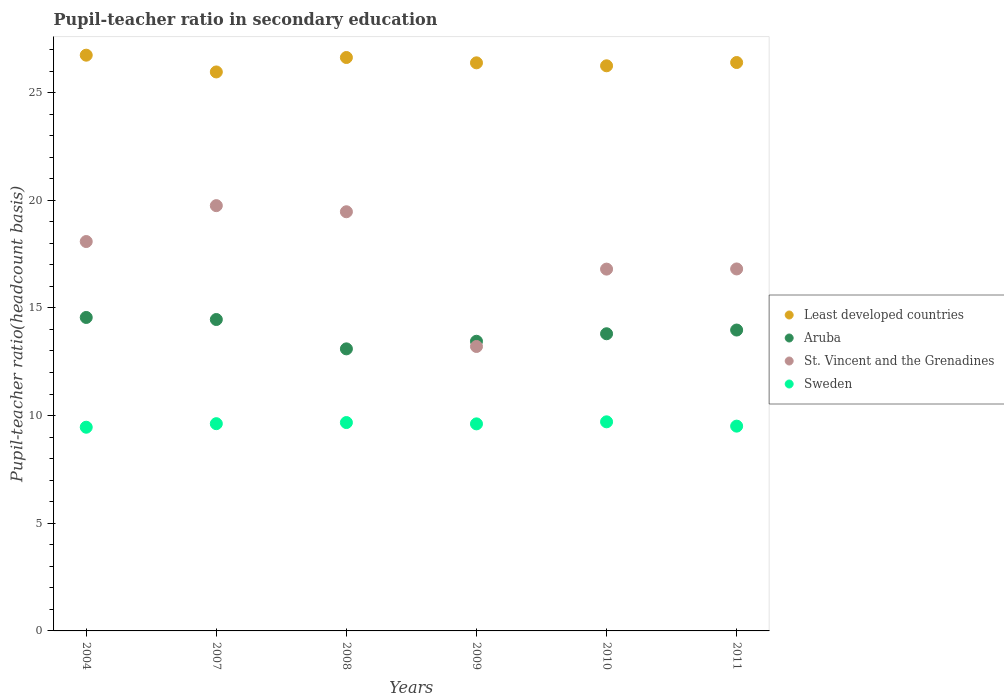Is the number of dotlines equal to the number of legend labels?
Ensure brevity in your answer.  Yes. What is the pupil-teacher ratio in secondary education in Aruba in 2009?
Make the answer very short. 13.45. Across all years, what is the maximum pupil-teacher ratio in secondary education in Sweden?
Provide a succinct answer. 9.71. Across all years, what is the minimum pupil-teacher ratio in secondary education in Aruba?
Make the answer very short. 13.1. In which year was the pupil-teacher ratio in secondary education in Aruba minimum?
Provide a short and direct response. 2008. What is the total pupil-teacher ratio in secondary education in Aruba in the graph?
Keep it short and to the point. 83.35. What is the difference between the pupil-teacher ratio in secondary education in St. Vincent and the Grenadines in 2004 and that in 2011?
Keep it short and to the point. 1.27. What is the difference between the pupil-teacher ratio in secondary education in Aruba in 2009 and the pupil-teacher ratio in secondary education in Least developed countries in 2010?
Your response must be concise. -12.79. What is the average pupil-teacher ratio in secondary education in St. Vincent and the Grenadines per year?
Your answer should be compact. 17.35. In the year 2007, what is the difference between the pupil-teacher ratio in secondary education in Sweden and pupil-teacher ratio in secondary education in Aruba?
Ensure brevity in your answer.  -4.84. What is the ratio of the pupil-teacher ratio in secondary education in Aruba in 2004 to that in 2009?
Make the answer very short. 1.08. Is the pupil-teacher ratio in secondary education in Sweden in 2009 less than that in 2010?
Keep it short and to the point. Yes. Is the difference between the pupil-teacher ratio in secondary education in Sweden in 2008 and 2009 greater than the difference between the pupil-teacher ratio in secondary education in Aruba in 2008 and 2009?
Keep it short and to the point. Yes. What is the difference between the highest and the second highest pupil-teacher ratio in secondary education in Aruba?
Your answer should be compact. 0.1. What is the difference between the highest and the lowest pupil-teacher ratio in secondary education in St. Vincent and the Grenadines?
Your answer should be compact. 6.54. Is the sum of the pupil-teacher ratio in secondary education in Aruba in 2004 and 2010 greater than the maximum pupil-teacher ratio in secondary education in Least developed countries across all years?
Give a very brief answer. Yes. Is it the case that in every year, the sum of the pupil-teacher ratio in secondary education in Least developed countries and pupil-teacher ratio in secondary education in Aruba  is greater than the sum of pupil-teacher ratio in secondary education in St. Vincent and the Grenadines and pupil-teacher ratio in secondary education in Sweden?
Give a very brief answer. Yes. Does the pupil-teacher ratio in secondary education in St. Vincent and the Grenadines monotonically increase over the years?
Offer a very short reply. No. Is the pupil-teacher ratio in secondary education in St. Vincent and the Grenadines strictly greater than the pupil-teacher ratio in secondary education in Sweden over the years?
Keep it short and to the point. Yes. Is the pupil-teacher ratio in secondary education in Sweden strictly less than the pupil-teacher ratio in secondary education in St. Vincent and the Grenadines over the years?
Ensure brevity in your answer.  Yes. How many years are there in the graph?
Your response must be concise. 6. Does the graph contain any zero values?
Give a very brief answer. No. Does the graph contain grids?
Provide a short and direct response. No. Where does the legend appear in the graph?
Offer a very short reply. Center right. What is the title of the graph?
Offer a terse response. Pupil-teacher ratio in secondary education. Does "Central Europe" appear as one of the legend labels in the graph?
Provide a short and direct response. No. What is the label or title of the Y-axis?
Your response must be concise. Pupil-teacher ratio(headcount basis). What is the Pupil-teacher ratio(headcount basis) of Least developed countries in 2004?
Your answer should be very brief. 26.74. What is the Pupil-teacher ratio(headcount basis) in Aruba in 2004?
Ensure brevity in your answer.  14.56. What is the Pupil-teacher ratio(headcount basis) in St. Vincent and the Grenadines in 2004?
Your answer should be compact. 18.08. What is the Pupil-teacher ratio(headcount basis) in Sweden in 2004?
Provide a succinct answer. 9.46. What is the Pupil-teacher ratio(headcount basis) of Least developed countries in 2007?
Offer a terse response. 25.96. What is the Pupil-teacher ratio(headcount basis) in Aruba in 2007?
Offer a terse response. 14.46. What is the Pupil-teacher ratio(headcount basis) in St. Vincent and the Grenadines in 2007?
Offer a terse response. 19.75. What is the Pupil-teacher ratio(headcount basis) of Sweden in 2007?
Make the answer very short. 9.62. What is the Pupil-teacher ratio(headcount basis) of Least developed countries in 2008?
Make the answer very short. 26.63. What is the Pupil-teacher ratio(headcount basis) of Aruba in 2008?
Give a very brief answer. 13.1. What is the Pupil-teacher ratio(headcount basis) of St. Vincent and the Grenadines in 2008?
Your answer should be compact. 19.47. What is the Pupil-teacher ratio(headcount basis) in Sweden in 2008?
Offer a terse response. 9.68. What is the Pupil-teacher ratio(headcount basis) in Least developed countries in 2009?
Ensure brevity in your answer.  26.38. What is the Pupil-teacher ratio(headcount basis) of Aruba in 2009?
Give a very brief answer. 13.45. What is the Pupil-teacher ratio(headcount basis) in St. Vincent and the Grenadines in 2009?
Offer a very short reply. 13.21. What is the Pupil-teacher ratio(headcount basis) of Sweden in 2009?
Make the answer very short. 9.62. What is the Pupil-teacher ratio(headcount basis) of Least developed countries in 2010?
Make the answer very short. 26.25. What is the Pupil-teacher ratio(headcount basis) of Aruba in 2010?
Provide a succinct answer. 13.8. What is the Pupil-teacher ratio(headcount basis) in St. Vincent and the Grenadines in 2010?
Offer a terse response. 16.8. What is the Pupil-teacher ratio(headcount basis) of Sweden in 2010?
Offer a terse response. 9.71. What is the Pupil-teacher ratio(headcount basis) of Least developed countries in 2011?
Make the answer very short. 26.4. What is the Pupil-teacher ratio(headcount basis) of Aruba in 2011?
Make the answer very short. 13.97. What is the Pupil-teacher ratio(headcount basis) of St. Vincent and the Grenadines in 2011?
Offer a very short reply. 16.81. What is the Pupil-teacher ratio(headcount basis) in Sweden in 2011?
Offer a terse response. 9.51. Across all years, what is the maximum Pupil-teacher ratio(headcount basis) in Least developed countries?
Make the answer very short. 26.74. Across all years, what is the maximum Pupil-teacher ratio(headcount basis) of Aruba?
Ensure brevity in your answer.  14.56. Across all years, what is the maximum Pupil-teacher ratio(headcount basis) in St. Vincent and the Grenadines?
Your answer should be very brief. 19.75. Across all years, what is the maximum Pupil-teacher ratio(headcount basis) of Sweden?
Offer a terse response. 9.71. Across all years, what is the minimum Pupil-teacher ratio(headcount basis) in Least developed countries?
Your answer should be very brief. 25.96. Across all years, what is the minimum Pupil-teacher ratio(headcount basis) of Aruba?
Make the answer very short. 13.1. Across all years, what is the minimum Pupil-teacher ratio(headcount basis) in St. Vincent and the Grenadines?
Provide a short and direct response. 13.21. Across all years, what is the minimum Pupil-teacher ratio(headcount basis) in Sweden?
Keep it short and to the point. 9.46. What is the total Pupil-teacher ratio(headcount basis) of Least developed countries in the graph?
Make the answer very short. 158.35. What is the total Pupil-teacher ratio(headcount basis) in Aruba in the graph?
Your response must be concise. 83.35. What is the total Pupil-teacher ratio(headcount basis) of St. Vincent and the Grenadines in the graph?
Your answer should be very brief. 104.12. What is the total Pupil-teacher ratio(headcount basis) in Sweden in the graph?
Offer a terse response. 57.6. What is the difference between the Pupil-teacher ratio(headcount basis) in Least developed countries in 2004 and that in 2007?
Give a very brief answer. 0.78. What is the difference between the Pupil-teacher ratio(headcount basis) of Aruba in 2004 and that in 2007?
Offer a terse response. 0.1. What is the difference between the Pupil-teacher ratio(headcount basis) in St. Vincent and the Grenadines in 2004 and that in 2007?
Your response must be concise. -1.67. What is the difference between the Pupil-teacher ratio(headcount basis) of Sweden in 2004 and that in 2007?
Ensure brevity in your answer.  -0.16. What is the difference between the Pupil-teacher ratio(headcount basis) in Least developed countries in 2004 and that in 2008?
Provide a succinct answer. 0.11. What is the difference between the Pupil-teacher ratio(headcount basis) in Aruba in 2004 and that in 2008?
Ensure brevity in your answer.  1.46. What is the difference between the Pupil-teacher ratio(headcount basis) in St. Vincent and the Grenadines in 2004 and that in 2008?
Give a very brief answer. -1.38. What is the difference between the Pupil-teacher ratio(headcount basis) in Sweden in 2004 and that in 2008?
Your response must be concise. -0.22. What is the difference between the Pupil-teacher ratio(headcount basis) of Least developed countries in 2004 and that in 2009?
Your answer should be very brief. 0.36. What is the difference between the Pupil-teacher ratio(headcount basis) of Aruba in 2004 and that in 2009?
Offer a very short reply. 1.11. What is the difference between the Pupil-teacher ratio(headcount basis) of St. Vincent and the Grenadines in 2004 and that in 2009?
Make the answer very short. 4.87. What is the difference between the Pupil-teacher ratio(headcount basis) of Sweden in 2004 and that in 2009?
Offer a terse response. -0.16. What is the difference between the Pupil-teacher ratio(headcount basis) of Least developed countries in 2004 and that in 2010?
Keep it short and to the point. 0.49. What is the difference between the Pupil-teacher ratio(headcount basis) of Aruba in 2004 and that in 2010?
Offer a terse response. 0.76. What is the difference between the Pupil-teacher ratio(headcount basis) in St. Vincent and the Grenadines in 2004 and that in 2010?
Provide a succinct answer. 1.28. What is the difference between the Pupil-teacher ratio(headcount basis) of Sweden in 2004 and that in 2010?
Provide a succinct answer. -0.25. What is the difference between the Pupil-teacher ratio(headcount basis) in Least developed countries in 2004 and that in 2011?
Offer a terse response. 0.34. What is the difference between the Pupil-teacher ratio(headcount basis) of Aruba in 2004 and that in 2011?
Offer a very short reply. 0.58. What is the difference between the Pupil-teacher ratio(headcount basis) in St. Vincent and the Grenadines in 2004 and that in 2011?
Offer a terse response. 1.27. What is the difference between the Pupil-teacher ratio(headcount basis) of Sweden in 2004 and that in 2011?
Offer a very short reply. -0.05. What is the difference between the Pupil-teacher ratio(headcount basis) in Least developed countries in 2007 and that in 2008?
Offer a very short reply. -0.67. What is the difference between the Pupil-teacher ratio(headcount basis) of Aruba in 2007 and that in 2008?
Offer a terse response. 1.36. What is the difference between the Pupil-teacher ratio(headcount basis) in St. Vincent and the Grenadines in 2007 and that in 2008?
Make the answer very short. 0.28. What is the difference between the Pupil-teacher ratio(headcount basis) in Sweden in 2007 and that in 2008?
Make the answer very short. -0.05. What is the difference between the Pupil-teacher ratio(headcount basis) in Least developed countries in 2007 and that in 2009?
Ensure brevity in your answer.  -0.42. What is the difference between the Pupil-teacher ratio(headcount basis) of Aruba in 2007 and that in 2009?
Keep it short and to the point. 1.01. What is the difference between the Pupil-teacher ratio(headcount basis) in St. Vincent and the Grenadines in 2007 and that in 2009?
Keep it short and to the point. 6.54. What is the difference between the Pupil-teacher ratio(headcount basis) of Sweden in 2007 and that in 2009?
Give a very brief answer. 0.01. What is the difference between the Pupil-teacher ratio(headcount basis) in Least developed countries in 2007 and that in 2010?
Offer a terse response. -0.29. What is the difference between the Pupil-teacher ratio(headcount basis) of Aruba in 2007 and that in 2010?
Offer a very short reply. 0.66. What is the difference between the Pupil-teacher ratio(headcount basis) in St. Vincent and the Grenadines in 2007 and that in 2010?
Make the answer very short. 2.95. What is the difference between the Pupil-teacher ratio(headcount basis) in Sweden in 2007 and that in 2010?
Your answer should be compact. -0.09. What is the difference between the Pupil-teacher ratio(headcount basis) in Least developed countries in 2007 and that in 2011?
Your answer should be very brief. -0.44. What is the difference between the Pupil-teacher ratio(headcount basis) of Aruba in 2007 and that in 2011?
Provide a short and direct response. 0.49. What is the difference between the Pupil-teacher ratio(headcount basis) in St. Vincent and the Grenadines in 2007 and that in 2011?
Provide a short and direct response. 2.94. What is the difference between the Pupil-teacher ratio(headcount basis) in Sweden in 2007 and that in 2011?
Your answer should be very brief. 0.11. What is the difference between the Pupil-teacher ratio(headcount basis) of Least developed countries in 2008 and that in 2009?
Your response must be concise. 0.25. What is the difference between the Pupil-teacher ratio(headcount basis) in Aruba in 2008 and that in 2009?
Provide a short and direct response. -0.35. What is the difference between the Pupil-teacher ratio(headcount basis) in St. Vincent and the Grenadines in 2008 and that in 2009?
Make the answer very short. 6.26. What is the difference between the Pupil-teacher ratio(headcount basis) of Sweden in 2008 and that in 2009?
Keep it short and to the point. 0.06. What is the difference between the Pupil-teacher ratio(headcount basis) of Least developed countries in 2008 and that in 2010?
Your response must be concise. 0.38. What is the difference between the Pupil-teacher ratio(headcount basis) of Aruba in 2008 and that in 2010?
Make the answer very short. -0.7. What is the difference between the Pupil-teacher ratio(headcount basis) in St. Vincent and the Grenadines in 2008 and that in 2010?
Provide a short and direct response. 2.66. What is the difference between the Pupil-teacher ratio(headcount basis) in Sweden in 2008 and that in 2010?
Provide a succinct answer. -0.03. What is the difference between the Pupil-teacher ratio(headcount basis) in Least developed countries in 2008 and that in 2011?
Provide a short and direct response. 0.23. What is the difference between the Pupil-teacher ratio(headcount basis) of Aruba in 2008 and that in 2011?
Your answer should be compact. -0.87. What is the difference between the Pupil-teacher ratio(headcount basis) in St. Vincent and the Grenadines in 2008 and that in 2011?
Your response must be concise. 2.66. What is the difference between the Pupil-teacher ratio(headcount basis) of Sweden in 2008 and that in 2011?
Keep it short and to the point. 0.17. What is the difference between the Pupil-teacher ratio(headcount basis) of Least developed countries in 2009 and that in 2010?
Your response must be concise. 0.14. What is the difference between the Pupil-teacher ratio(headcount basis) of Aruba in 2009 and that in 2010?
Provide a short and direct response. -0.35. What is the difference between the Pupil-teacher ratio(headcount basis) in St. Vincent and the Grenadines in 2009 and that in 2010?
Offer a terse response. -3.59. What is the difference between the Pupil-teacher ratio(headcount basis) in Sweden in 2009 and that in 2010?
Ensure brevity in your answer.  -0.1. What is the difference between the Pupil-teacher ratio(headcount basis) of Least developed countries in 2009 and that in 2011?
Ensure brevity in your answer.  -0.01. What is the difference between the Pupil-teacher ratio(headcount basis) of Aruba in 2009 and that in 2011?
Your answer should be very brief. -0.52. What is the difference between the Pupil-teacher ratio(headcount basis) of St. Vincent and the Grenadines in 2009 and that in 2011?
Keep it short and to the point. -3.6. What is the difference between the Pupil-teacher ratio(headcount basis) of Sweden in 2009 and that in 2011?
Your answer should be compact. 0.1. What is the difference between the Pupil-teacher ratio(headcount basis) in Least developed countries in 2010 and that in 2011?
Offer a very short reply. -0.15. What is the difference between the Pupil-teacher ratio(headcount basis) of Aruba in 2010 and that in 2011?
Offer a terse response. -0.17. What is the difference between the Pupil-teacher ratio(headcount basis) of St. Vincent and the Grenadines in 2010 and that in 2011?
Provide a short and direct response. -0.01. What is the difference between the Pupil-teacher ratio(headcount basis) of Sweden in 2010 and that in 2011?
Ensure brevity in your answer.  0.2. What is the difference between the Pupil-teacher ratio(headcount basis) in Least developed countries in 2004 and the Pupil-teacher ratio(headcount basis) in Aruba in 2007?
Keep it short and to the point. 12.28. What is the difference between the Pupil-teacher ratio(headcount basis) of Least developed countries in 2004 and the Pupil-teacher ratio(headcount basis) of St. Vincent and the Grenadines in 2007?
Your answer should be compact. 6.99. What is the difference between the Pupil-teacher ratio(headcount basis) of Least developed countries in 2004 and the Pupil-teacher ratio(headcount basis) of Sweden in 2007?
Your response must be concise. 17.11. What is the difference between the Pupil-teacher ratio(headcount basis) in Aruba in 2004 and the Pupil-teacher ratio(headcount basis) in St. Vincent and the Grenadines in 2007?
Ensure brevity in your answer.  -5.19. What is the difference between the Pupil-teacher ratio(headcount basis) of Aruba in 2004 and the Pupil-teacher ratio(headcount basis) of Sweden in 2007?
Give a very brief answer. 4.93. What is the difference between the Pupil-teacher ratio(headcount basis) in St. Vincent and the Grenadines in 2004 and the Pupil-teacher ratio(headcount basis) in Sweden in 2007?
Make the answer very short. 8.46. What is the difference between the Pupil-teacher ratio(headcount basis) in Least developed countries in 2004 and the Pupil-teacher ratio(headcount basis) in Aruba in 2008?
Make the answer very short. 13.64. What is the difference between the Pupil-teacher ratio(headcount basis) of Least developed countries in 2004 and the Pupil-teacher ratio(headcount basis) of St. Vincent and the Grenadines in 2008?
Offer a very short reply. 7.27. What is the difference between the Pupil-teacher ratio(headcount basis) in Least developed countries in 2004 and the Pupil-teacher ratio(headcount basis) in Sweden in 2008?
Offer a very short reply. 17.06. What is the difference between the Pupil-teacher ratio(headcount basis) in Aruba in 2004 and the Pupil-teacher ratio(headcount basis) in St. Vincent and the Grenadines in 2008?
Keep it short and to the point. -4.91. What is the difference between the Pupil-teacher ratio(headcount basis) of Aruba in 2004 and the Pupil-teacher ratio(headcount basis) of Sweden in 2008?
Your response must be concise. 4.88. What is the difference between the Pupil-teacher ratio(headcount basis) in St. Vincent and the Grenadines in 2004 and the Pupil-teacher ratio(headcount basis) in Sweden in 2008?
Ensure brevity in your answer.  8.41. What is the difference between the Pupil-teacher ratio(headcount basis) in Least developed countries in 2004 and the Pupil-teacher ratio(headcount basis) in Aruba in 2009?
Your answer should be very brief. 13.29. What is the difference between the Pupil-teacher ratio(headcount basis) in Least developed countries in 2004 and the Pupil-teacher ratio(headcount basis) in St. Vincent and the Grenadines in 2009?
Your response must be concise. 13.53. What is the difference between the Pupil-teacher ratio(headcount basis) of Least developed countries in 2004 and the Pupil-teacher ratio(headcount basis) of Sweden in 2009?
Keep it short and to the point. 17.12. What is the difference between the Pupil-teacher ratio(headcount basis) in Aruba in 2004 and the Pupil-teacher ratio(headcount basis) in St. Vincent and the Grenadines in 2009?
Offer a very short reply. 1.35. What is the difference between the Pupil-teacher ratio(headcount basis) in Aruba in 2004 and the Pupil-teacher ratio(headcount basis) in Sweden in 2009?
Provide a short and direct response. 4.94. What is the difference between the Pupil-teacher ratio(headcount basis) in St. Vincent and the Grenadines in 2004 and the Pupil-teacher ratio(headcount basis) in Sweden in 2009?
Offer a very short reply. 8.47. What is the difference between the Pupil-teacher ratio(headcount basis) in Least developed countries in 2004 and the Pupil-teacher ratio(headcount basis) in Aruba in 2010?
Your answer should be compact. 12.94. What is the difference between the Pupil-teacher ratio(headcount basis) of Least developed countries in 2004 and the Pupil-teacher ratio(headcount basis) of St. Vincent and the Grenadines in 2010?
Provide a succinct answer. 9.94. What is the difference between the Pupil-teacher ratio(headcount basis) in Least developed countries in 2004 and the Pupil-teacher ratio(headcount basis) in Sweden in 2010?
Provide a succinct answer. 17.03. What is the difference between the Pupil-teacher ratio(headcount basis) of Aruba in 2004 and the Pupil-teacher ratio(headcount basis) of St. Vincent and the Grenadines in 2010?
Offer a terse response. -2.25. What is the difference between the Pupil-teacher ratio(headcount basis) of Aruba in 2004 and the Pupil-teacher ratio(headcount basis) of Sweden in 2010?
Offer a very short reply. 4.85. What is the difference between the Pupil-teacher ratio(headcount basis) in St. Vincent and the Grenadines in 2004 and the Pupil-teacher ratio(headcount basis) in Sweden in 2010?
Offer a very short reply. 8.37. What is the difference between the Pupil-teacher ratio(headcount basis) of Least developed countries in 2004 and the Pupil-teacher ratio(headcount basis) of Aruba in 2011?
Your answer should be compact. 12.76. What is the difference between the Pupil-teacher ratio(headcount basis) in Least developed countries in 2004 and the Pupil-teacher ratio(headcount basis) in St. Vincent and the Grenadines in 2011?
Your answer should be very brief. 9.93. What is the difference between the Pupil-teacher ratio(headcount basis) of Least developed countries in 2004 and the Pupil-teacher ratio(headcount basis) of Sweden in 2011?
Keep it short and to the point. 17.23. What is the difference between the Pupil-teacher ratio(headcount basis) of Aruba in 2004 and the Pupil-teacher ratio(headcount basis) of St. Vincent and the Grenadines in 2011?
Provide a short and direct response. -2.25. What is the difference between the Pupil-teacher ratio(headcount basis) of Aruba in 2004 and the Pupil-teacher ratio(headcount basis) of Sweden in 2011?
Provide a short and direct response. 5.05. What is the difference between the Pupil-teacher ratio(headcount basis) of St. Vincent and the Grenadines in 2004 and the Pupil-teacher ratio(headcount basis) of Sweden in 2011?
Offer a terse response. 8.57. What is the difference between the Pupil-teacher ratio(headcount basis) in Least developed countries in 2007 and the Pupil-teacher ratio(headcount basis) in Aruba in 2008?
Make the answer very short. 12.86. What is the difference between the Pupil-teacher ratio(headcount basis) of Least developed countries in 2007 and the Pupil-teacher ratio(headcount basis) of St. Vincent and the Grenadines in 2008?
Offer a terse response. 6.49. What is the difference between the Pupil-teacher ratio(headcount basis) of Least developed countries in 2007 and the Pupil-teacher ratio(headcount basis) of Sweden in 2008?
Ensure brevity in your answer.  16.28. What is the difference between the Pupil-teacher ratio(headcount basis) of Aruba in 2007 and the Pupil-teacher ratio(headcount basis) of St. Vincent and the Grenadines in 2008?
Provide a short and direct response. -5. What is the difference between the Pupil-teacher ratio(headcount basis) in Aruba in 2007 and the Pupil-teacher ratio(headcount basis) in Sweden in 2008?
Keep it short and to the point. 4.79. What is the difference between the Pupil-teacher ratio(headcount basis) in St. Vincent and the Grenadines in 2007 and the Pupil-teacher ratio(headcount basis) in Sweden in 2008?
Make the answer very short. 10.07. What is the difference between the Pupil-teacher ratio(headcount basis) in Least developed countries in 2007 and the Pupil-teacher ratio(headcount basis) in Aruba in 2009?
Your answer should be compact. 12.51. What is the difference between the Pupil-teacher ratio(headcount basis) in Least developed countries in 2007 and the Pupil-teacher ratio(headcount basis) in St. Vincent and the Grenadines in 2009?
Keep it short and to the point. 12.75. What is the difference between the Pupil-teacher ratio(headcount basis) in Least developed countries in 2007 and the Pupil-teacher ratio(headcount basis) in Sweden in 2009?
Make the answer very short. 16.34. What is the difference between the Pupil-teacher ratio(headcount basis) in Aruba in 2007 and the Pupil-teacher ratio(headcount basis) in St. Vincent and the Grenadines in 2009?
Make the answer very short. 1.25. What is the difference between the Pupil-teacher ratio(headcount basis) of Aruba in 2007 and the Pupil-teacher ratio(headcount basis) of Sweden in 2009?
Provide a succinct answer. 4.85. What is the difference between the Pupil-teacher ratio(headcount basis) in St. Vincent and the Grenadines in 2007 and the Pupil-teacher ratio(headcount basis) in Sweden in 2009?
Ensure brevity in your answer.  10.13. What is the difference between the Pupil-teacher ratio(headcount basis) in Least developed countries in 2007 and the Pupil-teacher ratio(headcount basis) in Aruba in 2010?
Provide a succinct answer. 12.16. What is the difference between the Pupil-teacher ratio(headcount basis) of Least developed countries in 2007 and the Pupil-teacher ratio(headcount basis) of St. Vincent and the Grenadines in 2010?
Offer a very short reply. 9.16. What is the difference between the Pupil-teacher ratio(headcount basis) in Least developed countries in 2007 and the Pupil-teacher ratio(headcount basis) in Sweden in 2010?
Ensure brevity in your answer.  16.25. What is the difference between the Pupil-teacher ratio(headcount basis) in Aruba in 2007 and the Pupil-teacher ratio(headcount basis) in St. Vincent and the Grenadines in 2010?
Your answer should be very brief. -2.34. What is the difference between the Pupil-teacher ratio(headcount basis) of Aruba in 2007 and the Pupil-teacher ratio(headcount basis) of Sweden in 2010?
Your answer should be compact. 4.75. What is the difference between the Pupil-teacher ratio(headcount basis) of St. Vincent and the Grenadines in 2007 and the Pupil-teacher ratio(headcount basis) of Sweden in 2010?
Your answer should be very brief. 10.04. What is the difference between the Pupil-teacher ratio(headcount basis) of Least developed countries in 2007 and the Pupil-teacher ratio(headcount basis) of Aruba in 2011?
Make the answer very short. 11.99. What is the difference between the Pupil-teacher ratio(headcount basis) in Least developed countries in 2007 and the Pupil-teacher ratio(headcount basis) in St. Vincent and the Grenadines in 2011?
Keep it short and to the point. 9.15. What is the difference between the Pupil-teacher ratio(headcount basis) of Least developed countries in 2007 and the Pupil-teacher ratio(headcount basis) of Sweden in 2011?
Your answer should be compact. 16.45. What is the difference between the Pupil-teacher ratio(headcount basis) of Aruba in 2007 and the Pupil-teacher ratio(headcount basis) of St. Vincent and the Grenadines in 2011?
Provide a succinct answer. -2.35. What is the difference between the Pupil-teacher ratio(headcount basis) in Aruba in 2007 and the Pupil-teacher ratio(headcount basis) in Sweden in 2011?
Your response must be concise. 4.95. What is the difference between the Pupil-teacher ratio(headcount basis) of St. Vincent and the Grenadines in 2007 and the Pupil-teacher ratio(headcount basis) of Sweden in 2011?
Give a very brief answer. 10.24. What is the difference between the Pupil-teacher ratio(headcount basis) in Least developed countries in 2008 and the Pupil-teacher ratio(headcount basis) in Aruba in 2009?
Give a very brief answer. 13.18. What is the difference between the Pupil-teacher ratio(headcount basis) in Least developed countries in 2008 and the Pupil-teacher ratio(headcount basis) in St. Vincent and the Grenadines in 2009?
Offer a terse response. 13.42. What is the difference between the Pupil-teacher ratio(headcount basis) in Least developed countries in 2008 and the Pupil-teacher ratio(headcount basis) in Sweden in 2009?
Keep it short and to the point. 17.01. What is the difference between the Pupil-teacher ratio(headcount basis) in Aruba in 2008 and the Pupil-teacher ratio(headcount basis) in St. Vincent and the Grenadines in 2009?
Your answer should be very brief. -0.11. What is the difference between the Pupil-teacher ratio(headcount basis) in Aruba in 2008 and the Pupil-teacher ratio(headcount basis) in Sweden in 2009?
Offer a terse response. 3.48. What is the difference between the Pupil-teacher ratio(headcount basis) of St. Vincent and the Grenadines in 2008 and the Pupil-teacher ratio(headcount basis) of Sweden in 2009?
Your response must be concise. 9.85. What is the difference between the Pupil-teacher ratio(headcount basis) in Least developed countries in 2008 and the Pupil-teacher ratio(headcount basis) in Aruba in 2010?
Provide a short and direct response. 12.83. What is the difference between the Pupil-teacher ratio(headcount basis) in Least developed countries in 2008 and the Pupil-teacher ratio(headcount basis) in St. Vincent and the Grenadines in 2010?
Ensure brevity in your answer.  9.83. What is the difference between the Pupil-teacher ratio(headcount basis) in Least developed countries in 2008 and the Pupil-teacher ratio(headcount basis) in Sweden in 2010?
Offer a very short reply. 16.92. What is the difference between the Pupil-teacher ratio(headcount basis) in Aruba in 2008 and the Pupil-teacher ratio(headcount basis) in St. Vincent and the Grenadines in 2010?
Provide a short and direct response. -3.7. What is the difference between the Pupil-teacher ratio(headcount basis) of Aruba in 2008 and the Pupil-teacher ratio(headcount basis) of Sweden in 2010?
Keep it short and to the point. 3.39. What is the difference between the Pupil-teacher ratio(headcount basis) in St. Vincent and the Grenadines in 2008 and the Pupil-teacher ratio(headcount basis) in Sweden in 2010?
Offer a very short reply. 9.76. What is the difference between the Pupil-teacher ratio(headcount basis) in Least developed countries in 2008 and the Pupil-teacher ratio(headcount basis) in Aruba in 2011?
Your answer should be very brief. 12.66. What is the difference between the Pupil-teacher ratio(headcount basis) in Least developed countries in 2008 and the Pupil-teacher ratio(headcount basis) in St. Vincent and the Grenadines in 2011?
Your answer should be compact. 9.82. What is the difference between the Pupil-teacher ratio(headcount basis) of Least developed countries in 2008 and the Pupil-teacher ratio(headcount basis) of Sweden in 2011?
Make the answer very short. 17.12. What is the difference between the Pupil-teacher ratio(headcount basis) of Aruba in 2008 and the Pupil-teacher ratio(headcount basis) of St. Vincent and the Grenadines in 2011?
Ensure brevity in your answer.  -3.71. What is the difference between the Pupil-teacher ratio(headcount basis) in Aruba in 2008 and the Pupil-teacher ratio(headcount basis) in Sweden in 2011?
Provide a short and direct response. 3.59. What is the difference between the Pupil-teacher ratio(headcount basis) in St. Vincent and the Grenadines in 2008 and the Pupil-teacher ratio(headcount basis) in Sweden in 2011?
Provide a succinct answer. 9.96. What is the difference between the Pupil-teacher ratio(headcount basis) of Least developed countries in 2009 and the Pupil-teacher ratio(headcount basis) of Aruba in 2010?
Your answer should be very brief. 12.58. What is the difference between the Pupil-teacher ratio(headcount basis) of Least developed countries in 2009 and the Pupil-teacher ratio(headcount basis) of St. Vincent and the Grenadines in 2010?
Provide a short and direct response. 9.58. What is the difference between the Pupil-teacher ratio(headcount basis) of Least developed countries in 2009 and the Pupil-teacher ratio(headcount basis) of Sweden in 2010?
Provide a short and direct response. 16.67. What is the difference between the Pupil-teacher ratio(headcount basis) of Aruba in 2009 and the Pupil-teacher ratio(headcount basis) of St. Vincent and the Grenadines in 2010?
Your answer should be very brief. -3.35. What is the difference between the Pupil-teacher ratio(headcount basis) of Aruba in 2009 and the Pupil-teacher ratio(headcount basis) of Sweden in 2010?
Your answer should be compact. 3.74. What is the difference between the Pupil-teacher ratio(headcount basis) of St. Vincent and the Grenadines in 2009 and the Pupil-teacher ratio(headcount basis) of Sweden in 2010?
Provide a short and direct response. 3.5. What is the difference between the Pupil-teacher ratio(headcount basis) of Least developed countries in 2009 and the Pupil-teacher ratio(headcount basis) of Aruba in 2011?
Ensure brevity in your answer.  12.41. What is the difference between the Pupil-teacher ratio(headcount basis) of Least developed countries in 2009 and the Pupil-teacher ratio(headcount basis) of St. Vincent and the Grenadines in 2011?
Give a very brief answer. 9.57. What is the difference between the Pupil-teacher ratio(headcount basis) of Least developed countries in 2009 and the Pupil-teacher ratio(headcount basis) of Sweden in 2011?
Your response must be concise. 16.87. What is the difference between the Pupil-teacher ratio(headcount basis) of Aruba in 2009 and the Pupil-teacher ratio(headcount basis) of St. Vincent and the Grenadines in 2011?
Provide a short and direct response. -3.36. What is the difference between the Pupil-teacher ratio(headcount basis) of Aruba in 2009 and the Pupil-teacher ratio(headcount basis) of Sweden in 2011?
Provide a short and direct response. 3.94. What is the difference between the Pupil-teacher ratio(headcount basis) of St. Vincent and the Grenadines in 2009 and the Pupil-teacher ratio(headcount basis) of Sweden in 2011?
Your answer should be very brief. 3.7. What is the difference between the Pupil-teacher ratio(headcount basis) of Least developed countries in 2010 and the Pupil-teacher ratio(headcount basis) of Aruba in 2011?
Offer a very short reply. 12.27. What is the difference between the Pupil-teacher ratio(headcount basis) in Least developed countries in 2010 and the Pupil-teacher ratio(headcount basis) in St. Vincent and the Grenadines in 2011?
Make the answer very short. 9.43. What is the difference between the Pupil-teacher ratio(headcount basis) in Least developed countries in 2010 and the Pupil-teacher ratio(headcount basis) in Sweden in 2011?
Provide a succinct answer. 16.73. What is the difference between the Pupil-teacher ratio(headcount basis) of Aruba in 2010 and the Pupil-teacher ratio(headcount basis) of St. Vincent and the Grenadines in 2011?
Provide a succinct answer. -3.01. What is the difference between the Pupil-teacher ratio(headcount basis) in Aruba in 2010 and the Pupil-teacher ratio(headcount basis) in Sweden in 2011?
Ensure brevity in your answer.  4.29. What is the difference between the Pupil-teacher ratio(headcount basis) of St. Vincent and the Grenadines in 2010 and the Pupil-teacher ratio(headcount basis) of Sweden in 2011?
Provide a succinct answer. 7.29. What is the average Pupil-teacher ratio(headcount basis) of Least developed countries per year?
Provide a short and direct response. 26.39. What is the average Pupil-teacher ratio(headcount basis) in Aruba per year?
Make the answer very short. 13.89. What is the average Pupil-teacher ratio(headcount basis) in St. Vincent and the Grenadines per year?
Ensure brevity in your answer.  17.35. What is the average Pupil-teacher ratio(headcount basis) of Sweden per year?
Offer a very short reply. 9.6. In the year 2004, what is the difference between the Pupil-teacher ratio(headcount basis) in Least developed countries and Pupil-teacher ratio(headcount basis) in Aruba?
Your answer should be compact. 12.18. In the year 2004, what is the difference between the Pupil-teacher ratio(headcount basis) in Least developed countries and Pupil-teacher ratio(headcount basis) in St. Vincent and the Grenadines?
Offer a very short reply. 8.65. In the year 2004, what is the difference between the Pupil-teacher ratio(headcount basis) in Least developed countries and Pupil-teacher ratio(headcount basis) in Sweden?
Ensure brevity in your answer.  17.28. In the year 2004, what is the difference between the Pupil-teacher ratio(headcount basis) in Aruba and Pupil-teacher ratio(headcount basis) in St. Vincent and the Grenadines?
Offer a very short reply. -3.53. In the year 2004, what is the difference between the Pupil-teacher ratio(headcount basis) in Aruba and Pupil-teacher ratio(headcount basis) in Sweden?
Ensure brevity in your answer.  5.1. In the year 2004, what is the difference between the Pupil-teacher ratio(headcount basis) in St. Vincent and the Grenadines and Pupil-teacher ratio(headcount basis) in Sweden?
Your response must be concise. 8.62. In the year 2007, what is the difference between the Pupil-teacher ratio(headcount basis) in Least developed countries and Pupil-teacher ratio(headcount basis) in Aruba?
Offer a terse response. 11.5. In the year 2007, what is the difference between the Pupil-teacher ratio(headcount basis) of Least developed countries and Pupil-teacher ratio(headcount basis) of St. Vincent and the Grenadines?
Your answer should be very brief. 6.21. In the year 2007, what is the difference between the Pupil-teacher ratio(headcount basis) of Least developed countries and Pupil-teacher ratio(headcount basis) of Sweden?
Make the answer very short. 16.33. In the year 2007, what is the difference between the Pupil-teacher ratio(headcount basis) of Aruba and Pupil-teacher ratio(headcount basis) of St. Vincent and the Grenadines?
Give a very brief answer. -5.29. In the year 2007, what is the difference between the Pupil-teacher ratio(headcount basis) of Aruba and Pupil-teacher ratio(headcount basis) of Sweden?
Your response must be concise. 4.84. In the year 2007, what is the difference between the Pupil-teacher ratio(headcount basis) of St. Vincent and the Grenadines and Pupil-teacher ratio(headcount basis) of Sweden?
Provide a succinct answer. 10.13. In the year 2008, what is the difference between the Pupil-teacher ratio(headcount basis) of Least developed countries and Pupil-teacher ratio(headcount basis) of Aruba?
Your response must be concise. 13.53. In the year 2008, what is the difference between the Pupil-teacher ratio(headcount basis) of Least developed countries and Pupil-teacher ratio(headcount basis) of St. Vincent and the Grenadines?
Offer a very short reply. 7.16. In the year 2008, what is the difference between the Pupil-teacher ratio(headcount basis) of Least developed countries and Pupil-teacher ratio(headcount basis) of Sweden?
Provide a succinct answer. 16.95. In the year 2008, what is the difference between the Pupil-teacher ratio(headcount basis) in Aruba and Pupil-teacher ratio(headcount basis) in St. Vincent and the Grenadines?
Your answer should be compact. -6.37. In the year 2008, what is the difference between the Pupil-teacher ratio(headcount basis) of Aruba and Pupil-teacher ratio(headcount basis) of Sweden?
Your answer should be compact. 3.42. In the year 2008, what is the difference between the Pupil-teacher ratio(headcount basis) in St. Vincent and the Grenadines and Pupil-teacher ratio(headcount basis) in Sweden?
Your response must be concise. 9.79. In the year 2009, what is the difference between the Pupil-teacher ratio(headcount basis) in Least developed countries and Pupil-teacher ratio(headcount basis) in Aruba?
Your answer should be compact. 12.93. In the year 2009, what is the difference between the Pupil-teacher ratio(headcount basis) in Least developed countries and Pupil-teacher ratio(headcount basis) in St. Vincent and the Grenadines?
Make the answer very short. 13.17. In the year 2009, what is the difference between the Pupil-teacher ratio(headcount basis) in Least developed countries and Pupil-teacher ratio(headcount basis) in Sweden?
Your response must be concise. 16.77. In the year 2009, what is the difference between the Pupil-teacher ratio(headcount basis) in Aruba and Pupil-teacher ratio(headcount basis) in St. Vincent and the Grenadines?
Your response must be concise. 0.24. In the year 2009, what is the difference between the Pupil-teacher ratio(headcount basis) of Aruba and Pupil-teacher ratio(headcount basis) of Sweden?
Keep it short and to the point. 3.84. In the year 2009, what is the difference between the Pupil-teacher ratio(headcount basis) in St. Vincent and the Grenadines and Pupil-teacher ratio(headcount basis) in Sweden?
Your response must be concise. 3.59. In the year 2010, what is the difference between the Pupil-teacher ratio(headcount basis) in Least developed countries and Pupil-teacher ratio(headcount basis) in Aruba?
Your response must be concise. 12.44. In the year 2010, what is the difference between the Pupil-teacher ratio(headcount basis) of Least developed countries and Pupil-teacher ratio(headcount basis) of St. Vincent and the Grenadines?
Offer a terse response. 9.44. In the year 2010, what is the difference between the Pupil-teacher ratio(headcount basis) of Least developed countries and Pupil-teacher ratio(headcount basis) of Sweden?
Your answer should be compact. 16.53. In the year 2010, what is the difference between the Pupil-teacher ratio(headcount basis) of Aruba and Pupil-teacher ratio(headcount basis) of St. Vincent and the Grenadines?
Your response must be concise. -3. In the year 2010, what is the difference between the Pupil-teacher ratio(headcount basis) in Aruba and Pupil-teacher ratio(headcount basis) in Sweden?
Ensure brevity in your answer.  4.09. In the year 2010, what is the difference between the Pupil-teacher ratio(headcount basis) of St. Vincent and the Grenadines and Pupil-teacher ratio(headcount basis) of Sweden?
Your response must be concise. 7.09. In the year 2011, what is the difference between the Pupil-teacher ratio(headcount basis) of Least developed countries and Pupil-teacher ratio(headcount basis) of Aruba?
Offer a terse response. 12.42. In the year 2011, what is the difference between the Pupil-teacher ratio(headcount basis) of Least developed countries and Pupil-teacher ratio(headcount basis) of St. Vincent and the Grenadines?
Make the answer very short. 9.59. In the year 2011, what is the difference between the Pupil-teacher ratio(headcount basis) of Least developed countries and Pupil-teacher ratio(headcount basis) of Sweden?
Ensure brevity in your answer.  16.89. In the year 2011, what is the difference between the Pupil-teacher ratio(headcount basis) in Aruba and Pupil-teacher ratio(headcount basis) in St. Vincent and the Grenadines?
Keep it short and to the point. -2.84. In the year 2011, what is the difference between the Pupil-teacher ratio(headcount basis) in Aruba and Pupil-teacher ratio(headcount basis) in Sweden?
Your answer should be compact. 4.46. In the year 2011, what is the difference between the Pupil-teacher ratio(headcount basis) in St. Vincent and the Grenadines and Pupil-teacher ratio(headcount basis) in Sweden?
Make the answer very short. 7.3. What is the ratio of the Pupil-teacher ratio(headcount basis) in Least developed countries in 2004 to that in 2007?
Make the answer very short. 1.03. What is the ratio of the Pupil-teacher ratio(headcount basis) in Aruba in 2004 to that in 2007?
Your answer should be compact. 1.01. What is the ratio of the Pupil-teacher ratio(headcount basis) of St. Vincent and the Grenadines in 2004 to that in 2007?
Keep it short and to the point. 0.92. What is the ratio of the Pupil-teacher ratio(headcount basis) in Sweden in 2004 to that in 2007?
Provide a succinct answer. 0.98. What is the ratio of the Pupil-teacher ratio(headcount basis) of Aruba in 2004 to that in 2008?
Provide a short and direct response. 1.11. What is the ratio of the Pupil-teacher ratio(headcount basis) in St. Vincent and the Grenadines in 2004 to that in 2008?
Offer a very short reply. 0.93. What is the ratio of the Pupil-teacher ratio(headcount basis) of Sweden in 2004 to that in 2008?
Your response must be concise. 0.98. What is the ratio of the Pupil-teacher ratio(headcount basis) of Least developed countries in 2004 to that in 2009?
Your response must be concise. 1.01. What is the ratio of the Pupil-teacher ratio(headcount basis) of Aruba in 2004 to that in 2009?
Give a very brief answer. 1.08. What is the ratio of the Pupil-teacher ratio(headcount basis) of St. Vincent and the Grenadines in 2004 to that in 2009?
Give a very brief answer. 1.37. What is the ratio of the Pupil-teacher ratio(headcount basis) in Sweden in 2004 to that in 2009?
Keep it short and to the point. 0.98. What is the ratio of the Pupil-teacher ratio(headcount basis) in Least developed countries in 2004 to that in 2010?
Give a very brief answer. 1.02. What is the ratio of the Pupil-teacher ratio(headcount basis) in Aruba in 2004 to that in 2010?
Keep it short and to the point. 1.05. What is the ratio of the Pupil-teacher ratio(headcount basis) in St. Vincent and the Grenadines in 2004 to that in 2010?
Offer a very short reply. 1.08. What is the ratio of the Pupil-teacher ratio(headcount basis) of Sweden in 2004 to that in 2010?
Ensure brevity in your answer.  0.97. What is the ratio of the Pupil-teacher ratio(headcount basis) of Least developed countries in 2004 to that in 2011?
Provide a succinct answer. 1.01. What is the ratio of the Pupil-teacher ratio(headcount basis) of Aruba in 2004 to that in 2011?
Your response must be concise. 1.04. What is the ratio of the Pupil-teacher ratio(headcount basis) in St. Vincent and the Grenadines in 2004 to that in 2011?
Offer a very short reply. 1.08. What is the ratio of the Pupil-teacher ratio(headcount basis) in Sweden in 2004 to that in 2011?
Provide a succinct answer. 0.99. What is the ratio of the Pupil-teacher ratio(headcount basis) of Least developed countries in 2007 to that in 2008?
Offer a very short reply. 0.97. What is the ratio of the Pupil-teacher ratio(headcount basis) in Aruba in 2007 to that in 2008?
Provide a short and direct response. 1.1. What is the ratio of the Pupil-teacher ratio(headcount basis) of St. Vincent and the Grenadines in 2007 to that in 2008?
Give a very brief answer. 1.01. What is the ratio of the Pupil-teacher ratio(headcount basis) of Least developed countries in 2007 to that in 2009?
Provide a short and direct response. 0.98. What is the ratio of the Pupil-teacher ratio(headcount basis) of Aruba in 2007 to that in 2009?
Offer a very short reply. 1.08. What is the ratio of the Pupil-teacher ratio(headcount basis) of St. Vincent and the Grenadines in 2007 to that in 2009?
Provide a succinct answer. 1.5. What is the ratio of the Pupil-teacher ratio(headcount basis) in Sweden in 2007 to that in 2009?
Provide a succinct answer. 1. What is the ratio of the Pupil-teacher ratio(headcount basis) of Aruba in 2007 to that in 2010?
Ensure brevity in your answer.  1.05. What is the ratio of the Pupil-teacher ratio(headcount basis) of St. Vincent and the Grenadines in 2007 to that in 2010?
Keep it short and to the point. 1.18. What is the ratio of the Pupil-teacher ratio(headcount basis) of Sweden in 2007 to that in 2010?
Provide a short and direct response. 0.99. What is the ratio of the Pupil-teacher ratio(headcount basis) of Least developed countries in 2007 to that in 2011?
Provide a short and direct response. 0.98. What is the ratio of the Pupil-teacher ratio(headcount basis) of Aruba in 2007 to that in 2011?
Your response must be concise. 1.03. What is the ratio of the Pupil-teacher ratio(headcount basis) in St. Vincent and the Grenadines in 2007 to that in 2011?
Keep it short and to the point. 1.17. What is the ratio of the Pupil-teacher ratio(headcount basis) in Sweden in 2007 to that in 2011?
Give a very brief answer. 1.01. What is the ratio of the Pupil-teacher ratio(headcount basis) in Least developed countries in 2008 to that in 2009?
Keep it short and to the point. 1.01. What is the ratio of the Pupil-teacher ratio(headcount basis) of Aruba in 2008 to that in 2009?
Your answer should be very brief. 0.97. What is the ratio of the Pupil-teacher ratio(headcount basis) of St. Vincent and the Grenadines in 2008 to that in 2009?
Ensure brevity in your answer.  1.47. What is the ratio of the Pupil-teacher ratio(headcount basis) of Sweden in 2008 to that in 2009?
Give a very brief answer. 1.01. What is the ratio of the Pupil-teacher ratio(headcount basis) of Least developed countries in 2008 to that in 2010?
Provide a short and direct response. 1.01. What is the ratio of the Pupil-teacher ratio(headcount basis) of Aruba in 2008 to that in 2010?
Provide a short and direct response. 0.95. What is the ratio of the Pupil-teacher ratio(headcount basis) in St. Vincent and the Grenadines in 2008 to that in 2010?
Give a very brief answer. 1.16. What is the ratio of the Pupil-teacher ratio(headcount basis) in Sweden in 2008 to that in 2010?
Give a very brief answer. 1. What is the ratio of the Pupil-teacher ratio(headcount basis) of Least developed countries in 2008 to that in 2011?
Give a very brief answer. 1.01. What is the ratio of the Pupil-teacher ratio(headcount basis) of Aruba in 2008 to that in 2011?
Ensure brevity in your answer.  0.94. What is the ratio of the Pupil-teacher ratio(headcount basis) in St. Vincent and the Grenadines in 2008 to that in 2011?
Provide a succinct answer. 1.16. What is the ratio of the Pupil-teacher ratio(headcount basis) of Sweden in 2008 to that in 2011?
Give a very brief answer. 1.02. What is the ratio of the Pupil-teacher ratio(headcount basis) in Aruba in 2009 to that in 2010?
Offer a terse response. 0.97. What is the ratio of the Pupil-teacher ratio(headcount basis) of St. Vincent and the Grenadines in 2009 to that in 2010?
Ensure brevity in your answer.  0.79. What is the ratio of the Pupil-teacher ratio(headcount basis) in Sweden in 2009 to that in 2010?
Provide a short and direct response. 0.99. What is the ratio of the Pupil-teacher ratio(headcount basis) in Least developed countries in 2009 to that in 2011?
Give a very brief answer. 1. What is the ratio of the Pupil-teacher ratio(headcount basis) of Aruba in 2009 to that in 2011?
Make the answer very short. 0.96. What is the ratio of the Pupil-teacher ratio(headcount basis) of St. Vincent and the Grenadines in 2009 to that in 2011?
Keep it short and to the point. 0.79. What is the ratio of the Pupil-teacher ratio(headcount basis) of Aruba in 2010 to that in 2011?
Your answer should be very brief. 0.99. What is the ratio of the Pupil-teacher ratio(headcount basis) of St. Vincent and the Grenadines in 2010 to that in 2011?
Your response must be concise. 1. What is the ratio of the Pupil-teacher ratio(headcount basis) in Sweden in 2010 to that in 2011?
Provide a short and direct response. 1.02. What is the difference between the highest and the second highest Pupil-teacher ratio(headcount basis) of Least developed countries?
Provide a succinct answer. 0.11. What is the difference between the highest and the second highest Pupil-teacher ratio(headcount basis) of Aruba?
Offer a terse response. 0.1. What is the difference between the highest and the second highest Pupil-teacher ratio(headcount basis) of St. Vincent and the Grenadines?
Offer a terse response. 0.28. What is the difference between the highest and the second highest Pupil-teacher ratio(headcount basis) in Sweden?
Your answer should be compact. 0.03. What is the difference between the highest and the lowest Pupil-teacher ratio(headcount basis) in Least developed countries?
Keep it short and to the point. 0.78. What is the difference between the highest and the lowest Pupil-teacher ratio(headcount basis) of Aruba?
Your response must be concise. 1.46. What is the difference between the highest and the lowest Pupil-teacher ratio(headcount basis) in St. Vincent and the Grenadines?
Your answer should be very brief. 6.54. What is the difference between the highest and the lowest Pupil-teacher ratio(headcount basis) in Sweden?
Ensure brevity in your answer.  0.25. 